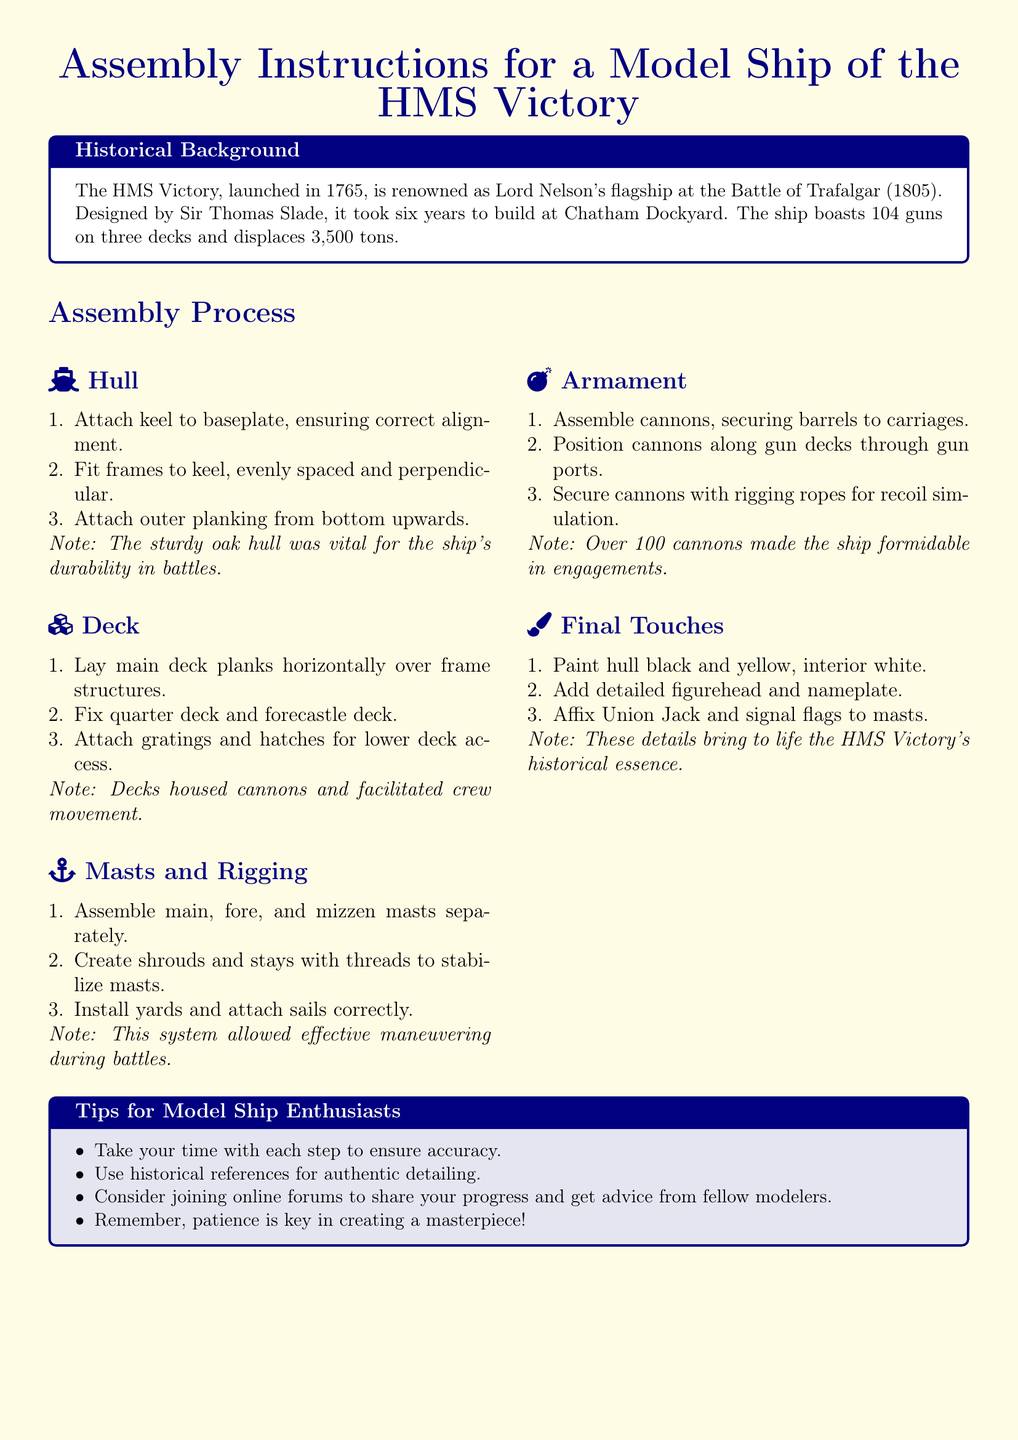What year was the HMS Victory launched? The document states that the HMS Victory was launched in the year 1765.
Answer: 1765 Who designed the HMS Victory? According to the historical background, the designer of the HMS Victory was Sir Thomas Slade.
Answer: Sir Thomas Slade How many guns does the HMS Victory have? The document mentions that the ship boasts 104 guns.
Answer: 104 guns What structural component is attached first in Hull assembly? The assembly process indicates that the keel is attached to the baseplate first.
Answer: Keel What is the function of the masts and rigging according to the document? The document specifies that the masts and rigging allow effective maneuvering during battles.
Answer: Effective maneuvering How many masts are assembled in the Masts and Rigging section? The instructions mention that three masts are assembled separately: main, fore, and mizzen.
Answer: Three masts What color is the hull painted? The document states that the hull is painted black and yellow.
Answer: Black and yellow Why are detailed figureheads and nameplates added? The final touches aim to bring to life the HMS Victory's historical essence.
Answer: Historical essence 